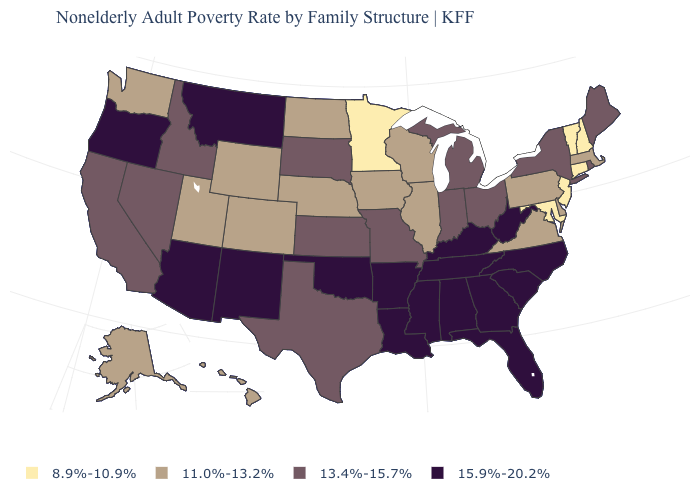Which states have the highest value in the USA?
Be succinct. Alabama, Arizona, Arkansas, Florida, Georgia, Kentucky, Louisiana, Mississippi, Montana, New Mexico, North Carolina, Oklahoma, Oregon, South Carolina, Tennessee, West Virginia. Among the states that border Connecticut , which have the lowest value?
Quick response, please. Massachusetts. What is the value of North Dakota?
Be succinct. 11.0%-13.2%. What is the value of Delaware?
Concise answer only. 11.0%-13.2%. What is the value of Idaho?
Give a very brief answer. 13.4%-15.7%. What is the value of Ohio?
Answer briefly. 13.4%-15.7%. Which states hav the highest value in the South?
Concise answer only. Alabama, Arkansas, Florida, Georgia, Kentucky, Louisiana, Mississippi, North Carolina, Oklahoma, South Carolina, Tennessee, West Virginia. Does Kansas have the lowest value in the USA?
Be succinct. No. What is the value of Missouri?
Write a very short answer. 13.4%-15.7%. What is the value of Rhode Island?
Write a very short answer. 13.4%-15.7%. Name the states that have a value in the range 8.9%-10.9%?
Keep it brief. Connecticut, Maryland, Minnesota, New Hampshire, New Jersey, Vermont. Which states have the highest value in the USA?
Answer briefly. Alabama, Arizona, Arkansas, Florida, Georgia, Kentucky, Louisiana, Mississippi, Montana, New Mexico, North Carolina, Oklahoma, Oregon, South Carolina, Tennessee, West Virginia. What is the highest value in states that border Washington?
Short answer required. 15.9%-20.2%. How many symbols are there in the legend?
Be succinct. 4. Does Illinois have the highest value in the USA?
Keep it brief. No. 